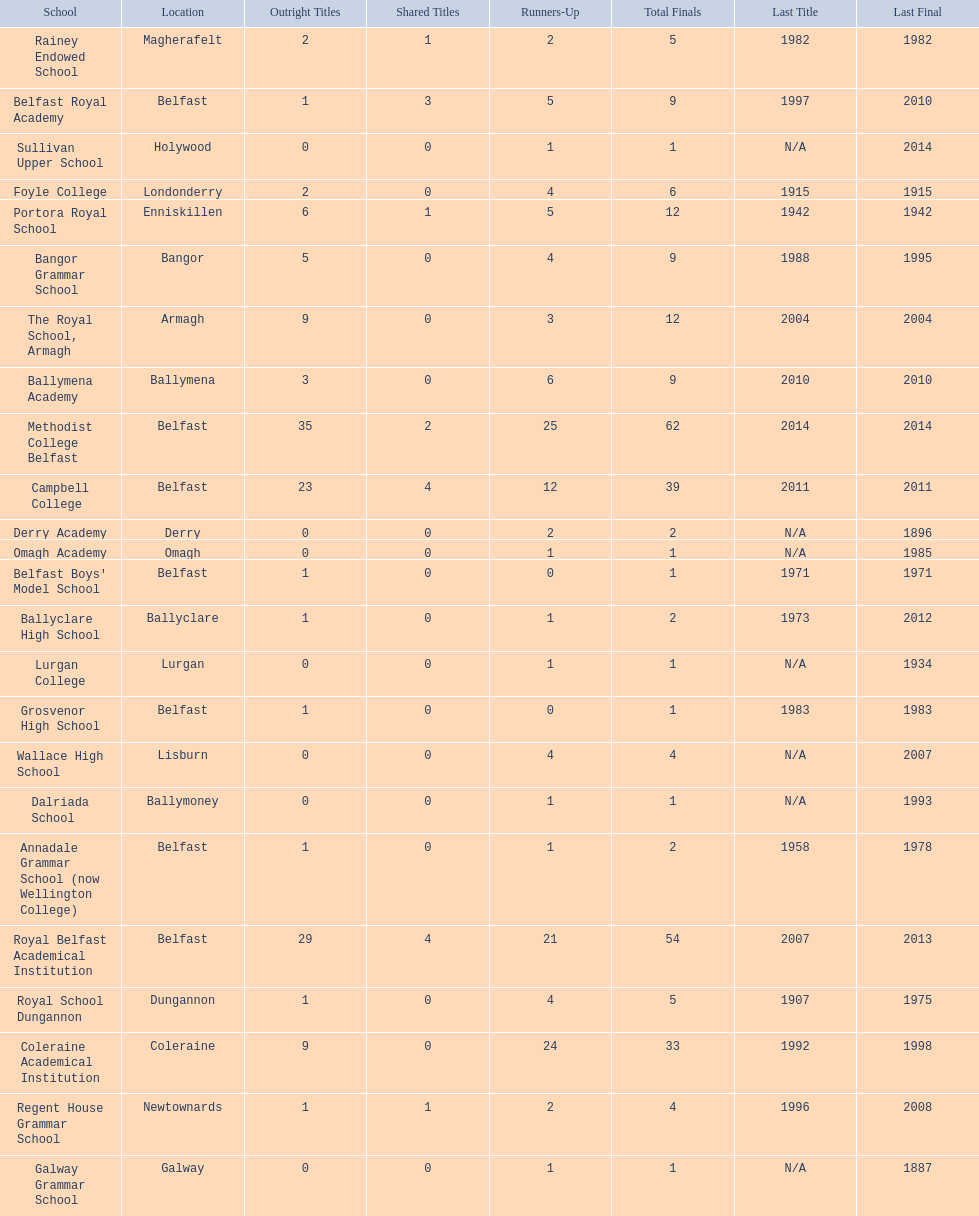Which schools are listed? Methodist College Belfast, Royal Belfast Academical Institution, Campbell College, Coleraine Academical Institution, The Royal School, Armagh, Portora Royal School, Bangor Grammar School, Ballymena Academy, Rainey Endowed School, Foyle College, Belfast Royal Academy, Regent House Grammar School, Royal School Dungannon, Annadale Grammar School (now Wellington College), Ballyclare High School, Belfast Boys' Model School, Grosvenor High School, Wallace High School, Derry Academy, Dalriada School, Galway Grammar School, Lurgan College, Omagh Academy, Sullivan Upper School. When did campbell college win the title last? 2011. When did regent house grammar school win the title last? 1996. Of those two who had the most recent title win? Campbell College. 